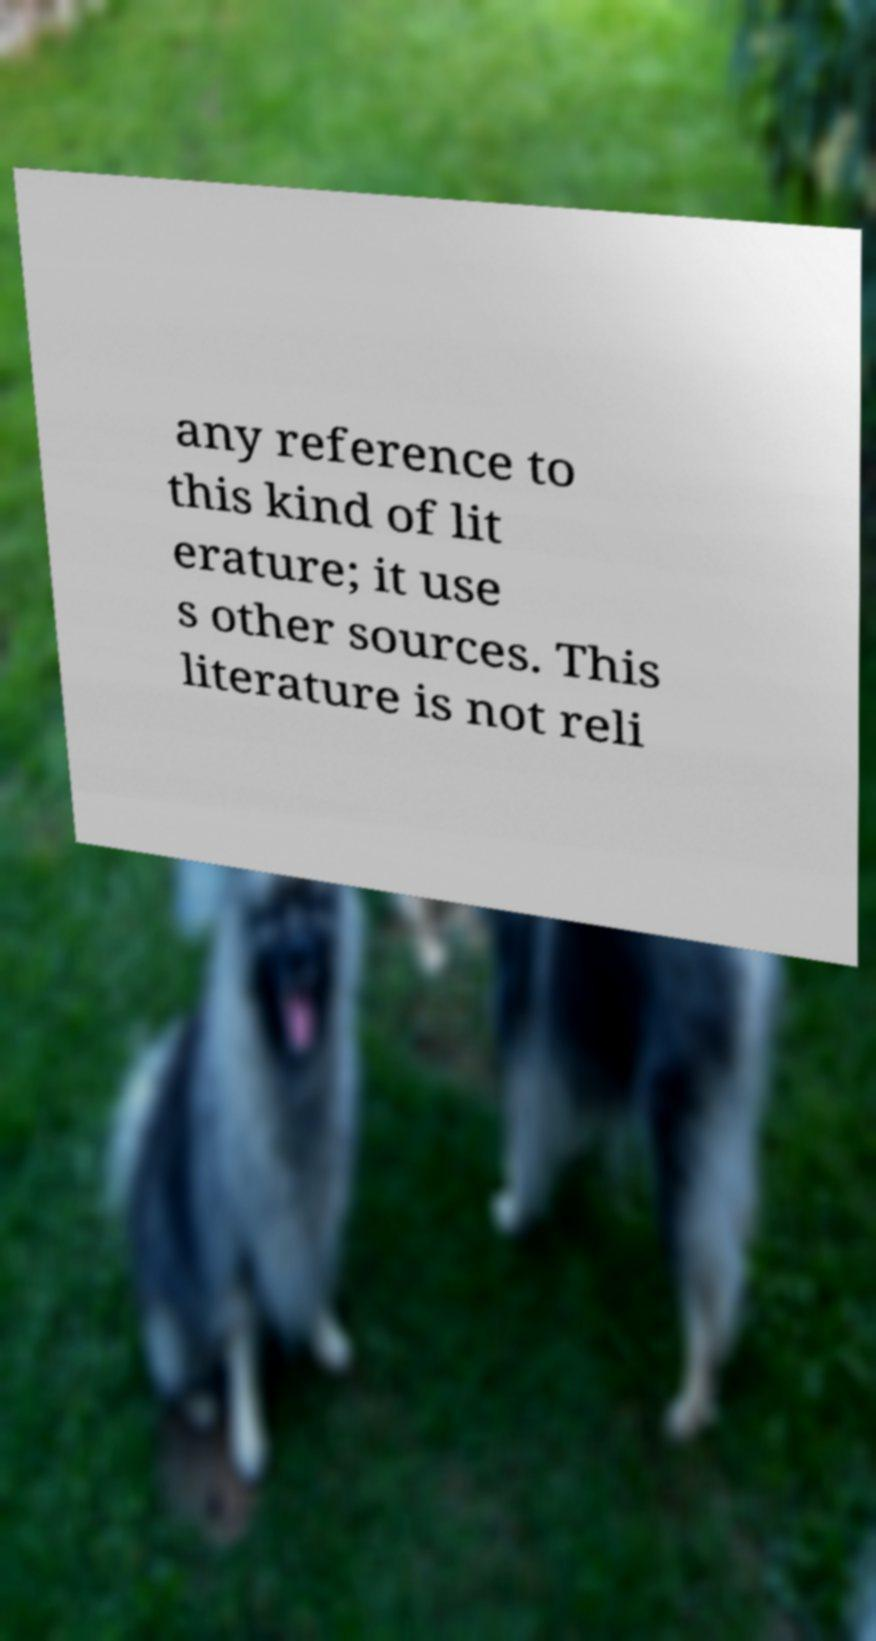Please read and relay the text visible in this image. What does it say? any reference to this kind of lit erature; it use s other sources. This literature is not reli 